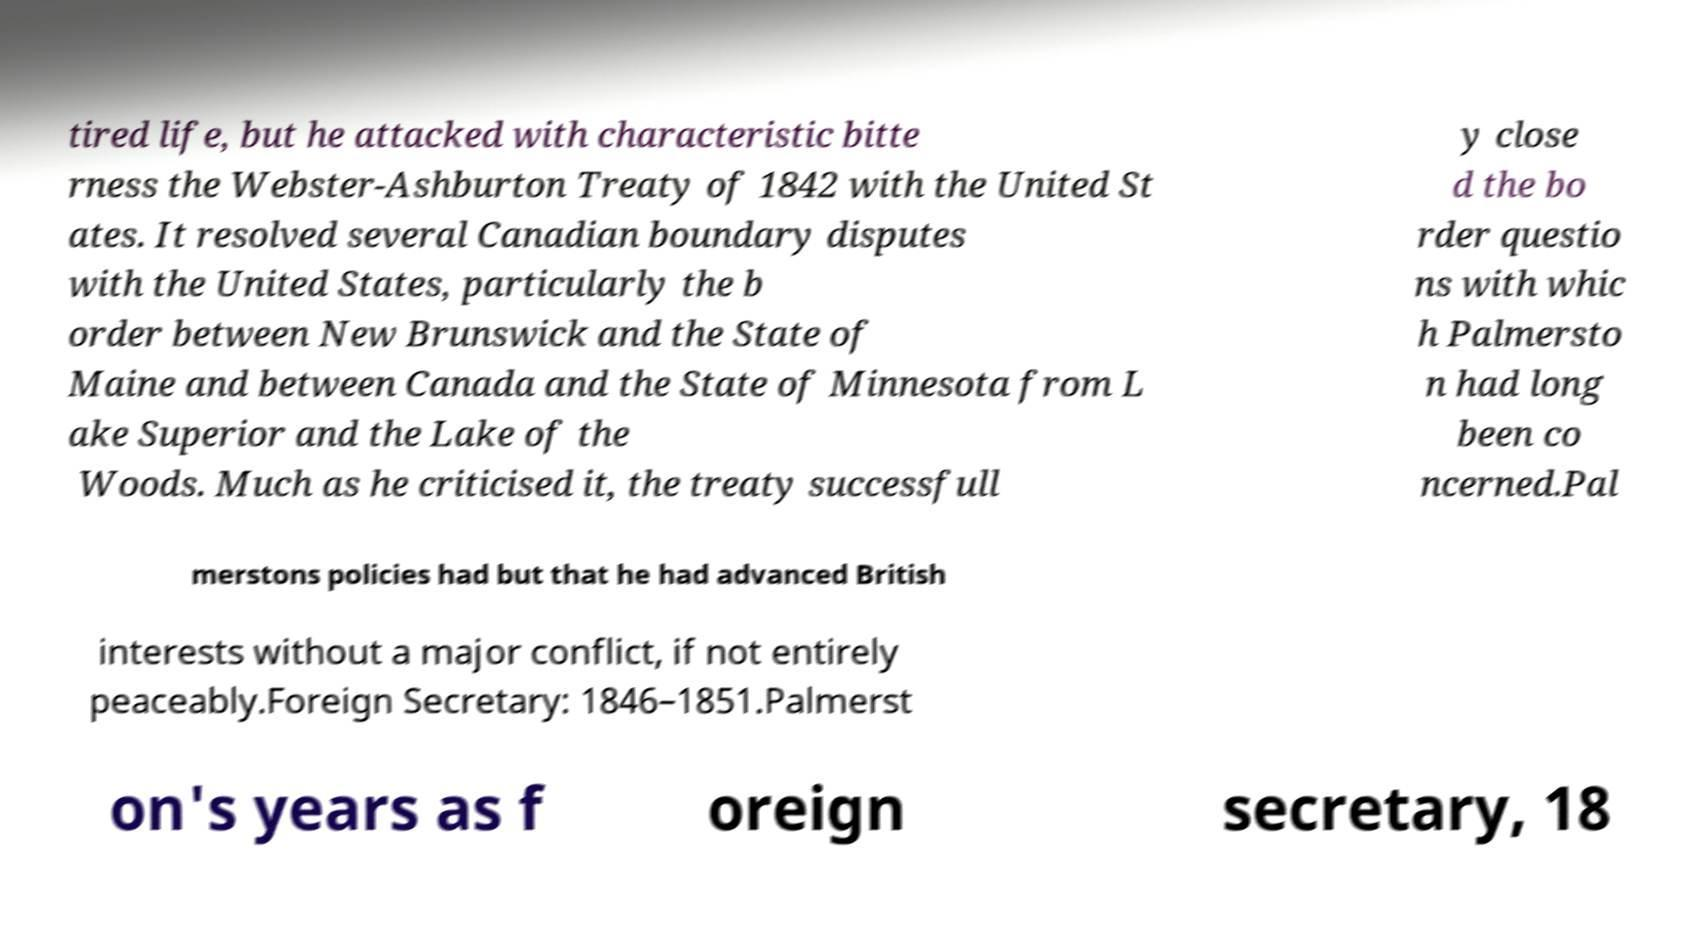There's text embedded in this image that I need extracted. Can you transcribe it verbatim? tired life, but he attacked with characteristic bitte rness the Webster-Ashburton Treaty of 1842 with the United St ates. It resolved several Canadian boundary disputes with the United States, particularly the b order between New Brunswick and the State of Maine and between Canada and the State of Minnesota from L ake Superior and the Lake of the Woods. Much as he criticised it, the treaty successfull y close d the bo rder questio ns with whic h Palmersto n had long been co ncerned.Pal merstons policies had but that he had advanced British interests without a major conflict, if not entirely peaceably.Foreign Secretary: 1846–1851.Palmerst on's years as f oreign secretary, 18 